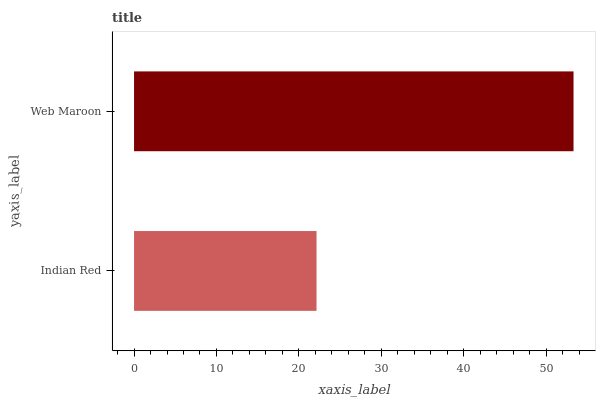Is Indian Red the minimum?
Answer yes or no. Yes. Is Web Maroon the maximum?
Answer yes or no. Yes. Is Web Maroon the minimum?
Answer yes or no. No. Is Web Maroon greater than Indian Red?
Answer yes or no. Yes. Is Indian Red less than Web Maroon?
Answer yes or no. Yes. Is Indian Red greater than Web Maroon?
Answer yes or no. No. Is Web Maroon less than Indian Red?
Answer yes or no. No. Is Web Maroon the high median?
Answer yes or no. Yes. Is Indian Red the low median?
Answer yes or no. Yes. Is Indian Red the high median?
Answer yes or no. No. Is Web Maroon the low median?
Answer yes or no. No. 